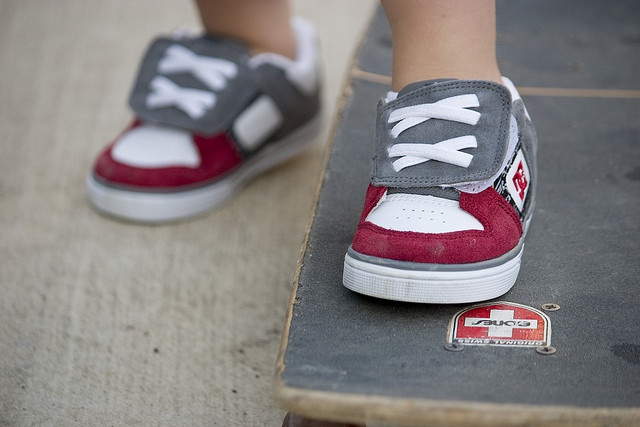Describe the objects in this image and their specific colors. I can see skateboard in gray and darkgray tones and people in gray, darkgray, lavender, and maroon tones in this image. 